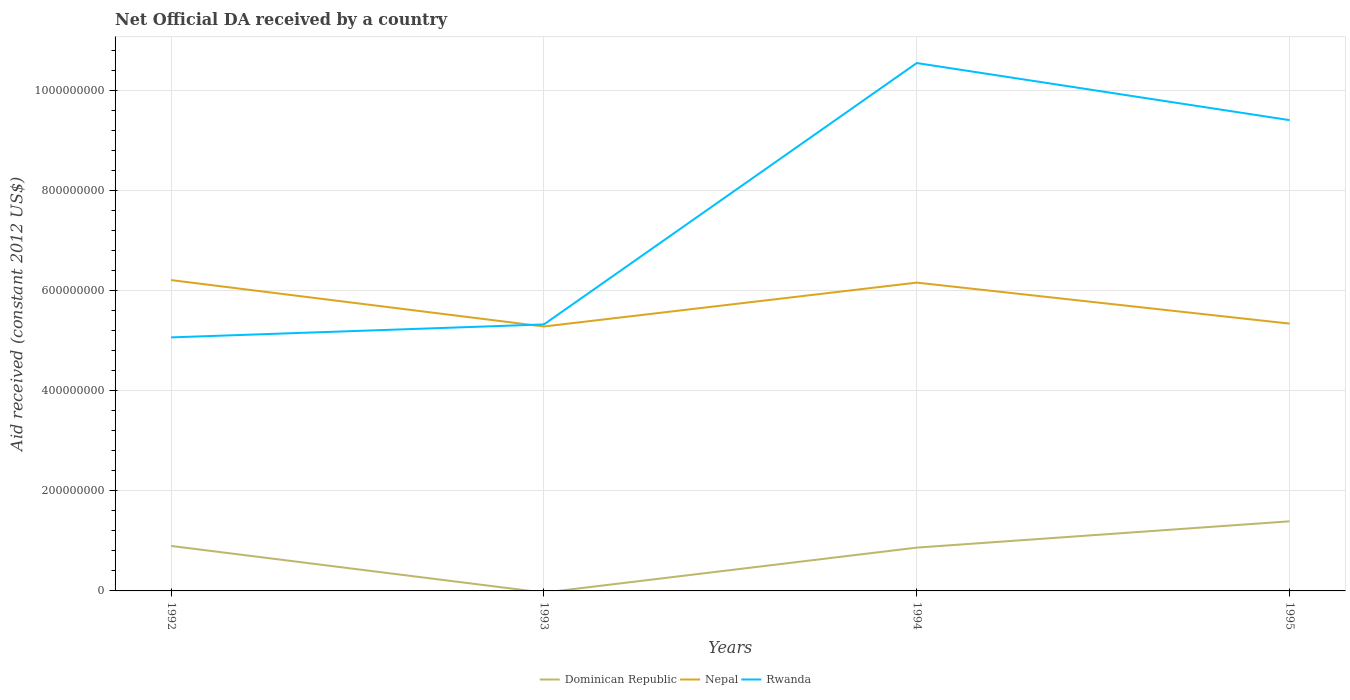How many different coloured lines are there?
Offer a very short reply. 3. Is the number of lines equal to the number of legend labels?
Keep it short and to the point. No. Across all years, what is the maximum net official development assistance aid received in Dominican Republic?
Provide a succinct answer. 0. What is the total net official development assistance aid received in Nepal in the graph?
Ensure brevity in your answer.  9.27e+07. What is the difference between the highest and the second highest net official development assistance aid received in Rwanda?
Give a very brief answer. 5.48e+08. How many lines are there?
Offer a very short reply. 3. How many years are there in the graph?
Keep it short and to the point. 4. Are the values on the major ticks of Y-axis written in scientific E-notation?
Provide a short and direct response. No. Does the graph contain any zero values?
Give a very brief answer. Yes. Does the graph contain grids?
Offer a very short reply. Yes. Where does the legend appear in the graph?
Offer a terse response. Bottom center. How many legend labels are there?
Your answer should be very brief. 3. How are the legend labels stacked?
Offer a terse response. Horizontal. What is the title of the graph?
Ensure brevity in your answer.  Net Official DA received by a country. Does "Uruguay" appear as one of the legend labels in the graph?
Offer a terse response. No. What is the label or title of the X-axis?
Make the answer very short. Years. What is the label or title of the Y-axis?
Make the answer very short. Aid received (constant 2012 US$). What is the Aid received (constant 2012 US$) in Dominican Republic in 1992?
Your response must be concise. 8.99e+07. What is the Aid received (constant 2012 US$) of Nepal in 1992?
Offer a very short reply. 6.21e+08. What is the Aid received (constant 2012 US$) in Rwanda in 1992?
Give a very brief answer. 5.07e+08. What is the Aid received (constant 2012 US$) of Nepal in 1993?
Offer a very short reply. 5.29e+08. What is the Aid received (constant 2012 US$) of Rwanda in 1993?
Offer a terse response. 5.33e+08. What is the Aid received (constant 2012 US$) of Dominican Republic in 1994?
Make the answer very short. 8.66e+07. What is the Aid received (constant 2012 US$) in Nepal in 1994?
Make the answer very short. 6.16e+08. What is the Aid received (constant 2012 US$) in Rwanda in 1994?
Provide a short and direct response. 1.06e+09. What is the Aid received (constant 2012 US$) of Dominican Republic in 1995?
Ensure brevity in your answer.  1.39e+08. What is the Aid received (constant 2012 US$) of Nepal in 1995?
Provide a succinct answer. 5.34e+08. What is the Aid received (constant 2012 US$) in Rwanda in 1995?
Ensure brevity in your answer.  9.41e+08. Across all years, what is the maximum Aid received (constant 2012 US$) of Dominican Republic?
Your answer should be very brief. 1.39e+08. Across all years, what is the maximum Aid received (constant 2012 US$) of Nepal?
Provide a succinct answer. 6.21e+08. Across all years, what is the maximum Aid received (constant 2012 US$) in Rwanda?
Offer a terse response. 1.06e+09. Across all years, what is the minimum Aid received (constant 2012 US$) in Dominican Republic?
Give a very brief answer. 0. Across all years, what is the minimum Aid received (constant 2012 US$) in Nepal?
Offer a very short reply. 5.29e+08. Across all years, what is the minimum Aid received (constant 2012 US$) in Rwanda?
Give a very brief answer. 5.07e+08. What is the total Aid received (constant 2012 US$) of Dominican Republic in the graph?
Ensure brevity in your answer.  3.16e+08. What is the total Aid received (constant 2012 US$) in Nepal in the graph?
Give a very brief answer. 2.30e+09. What is the total Aid received (constant 2012 US$) in Rwanda in the graph?
Offer a very short reply. 3.04e+09. What is the difference between the Aid received (constant 2012 US$) of Nepal in 1992 and that in 1993?
Provide a succinct answer. 9.27e+07. What is the difference between the Aid received (constant 2012 US$) of Rwanda in 1992 and that in 1993?
Provide a short and direct response. -2.59e+07. What is the difference between the Aid received (constant 2012 US$) in Dominican Republic in 1992 and that in 1994?
Your answer should be very brief. 3.34e+06. What is the difference between the Aid received (constant 2012 US$) in Nepal in 1992 and that in 1994?
Keep it short and to the point. 5.05e+06. What is the difference between the Aid received (constant 2012 US$) of Rwanda in 1992 and that in 1994?
Give a very brief answer. -5.48e+08. What is the difference between the Aid received (constant 2012 US$) in Dominican Republic in 1992 and that in 1995?
Your response must be concise. -4.92e+07. What is the difference between the Aid received (constant 2012 US$) in Nepal in 1992 and that in 1995?
Make the answer very short. 8.70e+07. What is the difference between the Aid received (constant 2012 US$) in Rwanda in 1992 and that in 1995?
Offer a terse response. -4.34e+08. What is the difference between the Aid received (constant 2012 US$) of Nepal in 1993 and that in 1994?
Keep it short and to the point. -8.77e+07. What is the difference between the Aid received (constant 2012 US$) in Rwanda in 1993 and that in 1994?
Provide a short and direct response. -5.22e+08. What is the difference between the Aid received (constant 2012 US$) of Nepal in 1993 and that in 1995?
Your response must be concise. -5.75e+06. What is the difference between the Aid received (constant 2012 US$) of Rwanda in 1993 and that in 1995?
Your answer should be very brief. -4.08e+08. What is the difference between the Aid received (constant 2012 US$) in Dominican Republic in 1994 and that in 1995?
Provide a succinct answer. -5.26e+07. What is the difference between the Aid received (constant 2012 US$) of Nepal in 1994 and that in 1995?
Provide a succinct answer. 8.19e+07. What is the difference between the Aid received (constant 2012 US$) of Rwanda in 1994 and that in 1995?
Your answer should be very brief. 1.14e+08. What is the difference between the Aid received (constant 2012 US$) of Dominican Republic in 1992 and the Aid received (constant 2012 US$) of Nepal in 1993?
Make the answer very short. -4.39e+08. What is the difference between the Aid received (constant 2012 US$) in Dominican Republic in 1992 and the Aid received (constant 2012 US$) in Rwanda in 1993?
Offer a terse response. -4.43e+08. What is the difference between the Aid received (constant 2012 US$) in Nepal in 1992 and the Aid received (constant 2012 US$) in Rwanda in 1993?
Offer a terse response. 8.86e+07. What is the difference between the Aid received (constant 2012 US$) in Dominican Republic in 1992 and the Aid received (constant 2012 US$) in Nepal in 1994?
Provide a succinct answer. -5.26e+08. What is the difference between the Aid received (constant 2012 US$) of Dominican Republic in 1992 and the Aid received (constant 2012 US$) of Rwanda in 1994?
Ensure brevity in your answer.  -9.65e+08. What is the difference between the Aid received (constant 2012 US$) of Nepal in 1992 and the Aid received (constant 2012 US$) of Rwanda in 1994?
Offer a terse response. -4.34e+08. What is the difference between the Aid received (constant 2012 US$) of Dominican Republic in 1992 and the Aid received (constant 2012 US$) of Nepal in 1995?
Keep it short and to the point. -4.44e+08. What is the difference between the Aid received (constant 2012 US$) in Dominican Republic in 1992 and the Aid received (constant 2012 US$) in Rwanda in 1995?
Offer a terse response. -8.51e+08. What is the difference between the Aid received (constant 2012 US$) in Nepal in 1992 and the Aid received (constant 2012 US$) in Rwanda in 1995?
Give a very brief answer. -3.20e+08. What is the difference between the Aid received (constant 2012 US$) of Nepal in 1993 and the Aid received (constant 2012 US$) of Rwanda in 1994?
Your answer should be very brief. -5.27e+08. What is the difference between the Aid received (constant 2012 US$) in Nepal in 1993 and the Aid received (constant 2012 US$) in Rwanda in 1995?
Make the answer very short. -4.12e+08. What is the difference between the Aid received (constant 2012 US$) of Dominican Republic in 1994 and the Aid received (constant 2012 US$) of Nepal in 1995?
Provide a short and direct response. -4.48e+08. What is the difference between the Aid received (constant 2012 US$) of Dominican Republic in 1994 and the Aid received (constant 2012 US$) of Rwanda in 1995?
Offer a very short reply. -8.54e+08. What is the difference between the Aid received (constant 2012 US$) of Nepal in 1994 and the Aid received (constant 2012 US$) of Rwanda in 1995?
Provide a short and direct response. -3.25e+08. What is the average Aid received (constant 2012 US$) in Dominican Republic per year?
Your response must be concise. 7.89e+07. What is the average Aid received (constant 2012 US$) of Nepal per year?
Keep it short and to the point. 5.75e+08. What is the average Aid received (constant 2012 US$) of Rwanda per year?
Provide a short and direct response. 7.59e+08. In the year 1992, what is the difference between the Aid received (constant 2012 US$) of Dominican Republic and Aid received (constant 2012 US$) of Nepal?
Ensure brevity in your answer.  -5.31e+08. In the year 1992, what is the difference between the Aid received (constant 2012 US$) of Dominican Republic and Aid received (constant 2012 US$) of Rwanda?
Provide a short and direct response. -4.17e+08. In the year 1992, what is the difference between the Aid received (constant 2012 US$) in Nepal and Aid received (constant 2012 US$) in Rwanda?
Offer a very short reply. 1.15e+08. In the year 1993, what is the difference between the Aid received (constant 2012 US$) in Nepal and Aid received (constant 2012 US$) in Rwanda?
Offer a very short reply. -4.10e+06. In the year 1994, what is the difference between the Aid received (constant 2012 US$) of Dominican Republic and Aid received (constant 2012 US$) of Nepal?
Keep it short and to the point. -5.30e+08. In the year 1994, what is the difference between the Aid received (constant 2012 US$) in Dominican Republic and Aid received (constant 2012 US$) in Rwanda?
Your answer should be compact. -9.69e+08. In the year 1994, what is the difference between the Aid received (constant 2012 US$) of Nepal and Aid received (constant 2012 US$) of Rwanda?
Your answer should be compact. -4.39e+08. In the year 1995, what is the difference between the Aid received (constant 2012 US$) in Dominican Republic and Aid received (constant 2012 US$) in Nepal?
Give a very brief answer. -3.95e+08. In the year 1995, what is the difference between the Aid received (constant 2012 US$) of Dominican Republic and Aid received (constant 2012 US$) of Rwanda?
Provide a succinct answer. -8.02e+08. In the year 1995, what is the difference between the Aid received (constant 2012 US$) of Nepal and Aid received (constant 2012 US$) of Rwanda?
Your answer should be very brief. -4.07e+08. What is the ratio of the Aid received (constant 2012 US$) of Nepal in 1992 to that in 1993?
Your answer should be compact. 1.18. What is the ratio of the Aid received (constant 2012 US$) in Rwanda in 1992 to that in 1993?
Offer a very short reply. 0.95. What is the ratio of the Aid received (constant 2012 US$) in Dominican Republic in 1992 to that in 1994?
Provide a short and direct response. 1.04. What is the ratio of the Aid received (constant 2012 US$) in Nepal in 1992 to that in 1994?
Keep it short and to the point. 1.01. What is the ratio of the Aid received (constant 2012 US$) of Rwanda in 1992 to that in 1994?
Offer a terse response. 0.48. What is the ratio of the Aid received (constant 2012 US$) in Dominican Republic in 1992 to that in 1995?
Make the answer very short. 0.65. What is the ratio of the Aid received (constant 2012 US$) of Nepal in 1992 to that in 1995?
Make the answer very short. 1.16. What is the ratio of the Aid received (constant 2012 US$) in Rwanda in 1992 to that in 1995?
Keep it short and to the point. 0.54. What is the ratio of the Aid received (constant 2012 US$) of Nepal in 1993 to that in 1994?
Ensure brevity in your answer.  0.86. What is the ratio of the Aid received (constant 2012 US$) of Rwanda in 1993 to that in 1994?
Ensure brevity in your answer.  0.5. What is the ratio of the Aid received (constant 2012 US$) in Nepal in 1993 to that in 1995?
Provide a succinct answer. 0.99. What is the ratio of the Aid received (constant 2012 US$) of Rwanda in 1993 to that in 1995?
Provide a short and direct response. 0.57. What is the ratio of the Aid received (constant 2012 US$) of Dominican Republic in 1994 to that in 1995?
Keep it short and to the point. 0.62. What is the ratio of the Aid received (constant 2012 US$) in Nepal in 1994 to that in 1995?
Ensure brevity in your answer.  1.15. What is the ratio of the Aid received (constant 2012 US$) of Rwanda in 1994 to that in 1995?
Your answer should be compact. 1.12. What is the difference between the highest and the second highest Aid received (constant 2012 US$) of Dominican Republic?
Keep it short and to the point. 4.92e+07. What is the difference between the highest and the second highest Aid received (constant 2012 US$) in Nepal?
Make the answer very short. 5.05e+06. What is the difference between the highest and the second highest Aid received (constant 2012 US$) of Rwanda?
Provide a succinct answer. 1.14e+08. What is the difference between the highest and the lowest Aid received (constant 2012 US$) in Dominican Republic?
Your answer should be compact. 1.39e+08. What is the difference between the highest and the lowest Aid received (constant 2012 US$) of Nepal?
Give a very brief answer. 9.27e+07. What is the difference between the highest and the lowest Aid received (constant 2012 US$) in Rwanda?
Provide a short and direct response. 5.48e+08. 